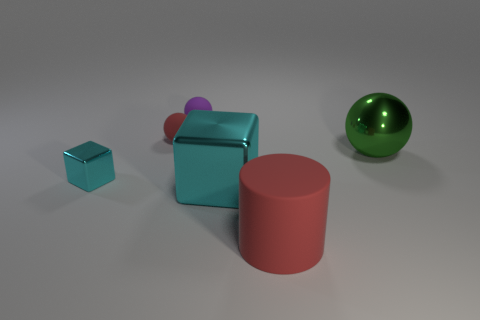What shape is the red object behind the rubber object in front of the large shiny object that is to the right of the large cylinder?
Provide a short and direct response. Sphere. There is a small rubber thing that is the same color as the large matte object; what shape is it?
Your response must be concise. Sphere. Are any matte cylinders visible?
Offer a very short reply. Yes. Does the red cylinder have the same size as the block that is on the right side of the tiny metal block?
Keep it short and to the point. Yes. There is a thing right of the large red matte object; are there any red cylinders right of it?
Offer a very short reply. No. There is a ball that is both in front of the purple object and left of the large metal block; what material is it?
Provide a succinct answer. Rubber. What is the color of the small ball to the left of the tiny sphere that is behind the red matte object behind the big matte object?
Keep it short and to the point. Red. There is another shiny thing that is the same size as the green object; what color is it?
Give a very brief answer. Cyan. Does the small metal thing have the same color as the small ball that is on the right side of the red rubber sphere?
Your answer should be very brief. No. The green object in front of the red matte thing to the left of the large matte cylinder is made of what material?
Your answer should be compact. Metal. 